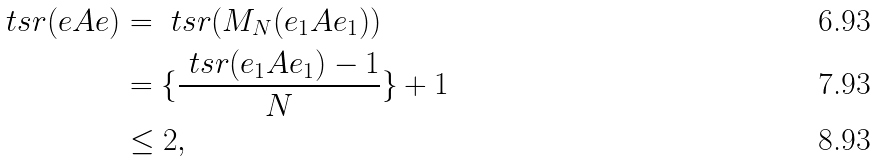<formula> <loc_0><loc_0><loc_500><loc_500>\ t s r ( e A e ) & = \ t s r ( M _ { N } ( e _ { 1 } A e _ { 1 } ) ) \\ & = \{ \frac { \ t s r ( e _ { 1 } A e _ { 1 } ) - 1 } { N } \} + 1 \\ & \leq 2 ,</formula> 